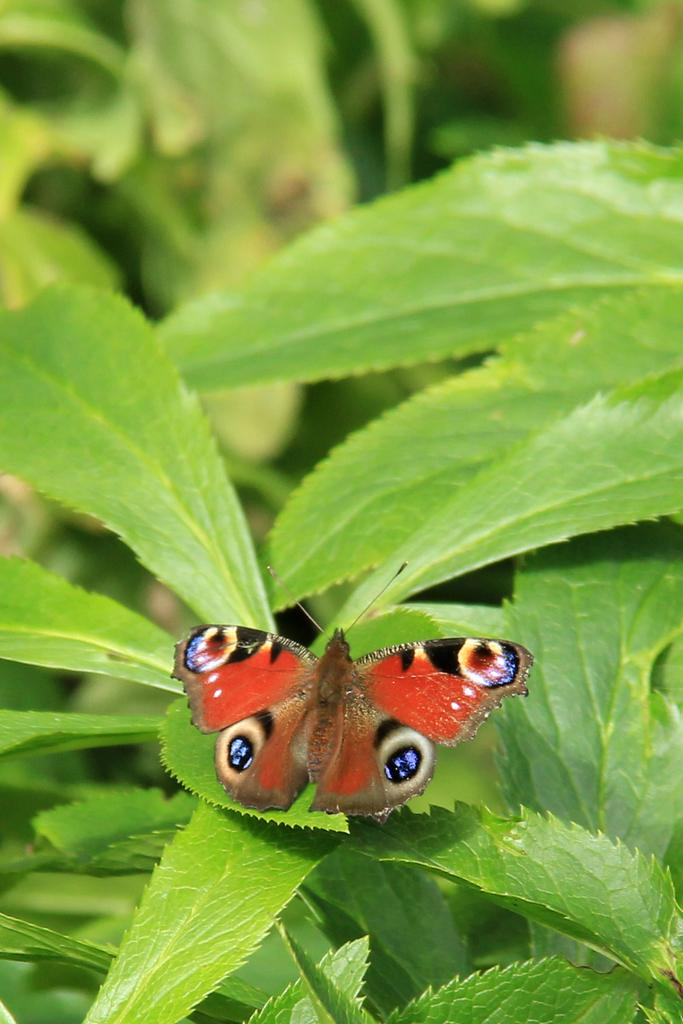What is the main subject of the image? The main subject of the image is a butterfly. Where is the butterfly located in the image? The butterfly is sitting on a leaf. What can be seen in the background of the image? There are leaves in the background of the image. What type of family is depicted in the image? There is no family depicted in the image; it features a butterfly sitting on a leaf. Does the butterfly in the image have any visible signs of disease? There is no indication of disease on the butterfly in the image. 